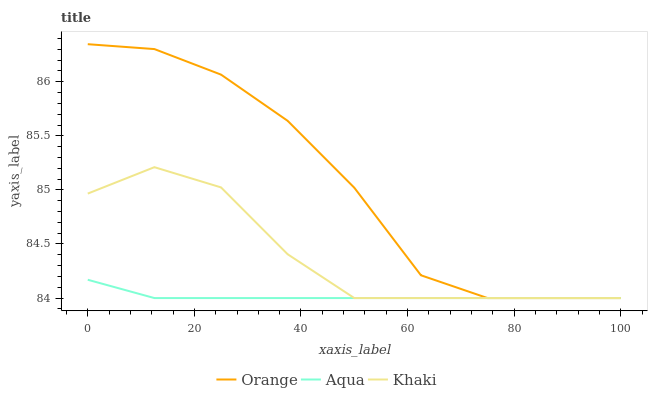Does Khaki have the minimum area under the curve?
Answer yes or no. No. Does Khaki have the maximum area under the curve?
Answer yes or no. No. Is Khaki the smoothest?
Answer yes or no. No. Is Khaki the roughest?
Answer yes or no. No. Does Khaki have the highest value?
Answer yes or no. No. 